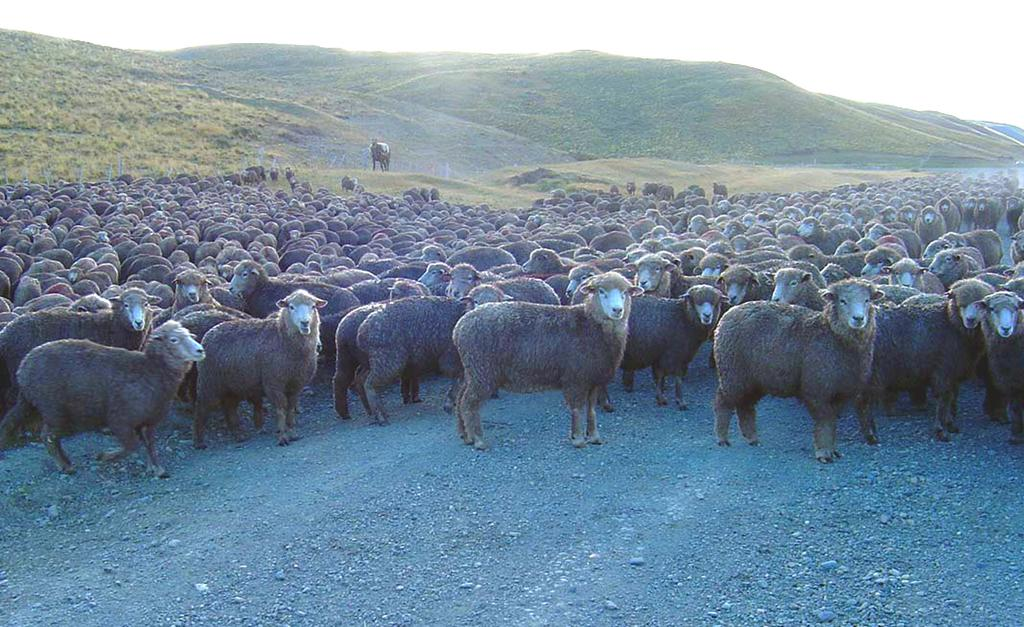What type of animals are in the image? There is a cattle of sheep in the image. What is located at the bottom of the image? There is a road at the bottom of the image. What can be seen in the background of the image? The background of the image includes mountains covered with green grass. What is visible at the top of the image? The sky is visible at the top of the image. How many goats are present in the image? There are no goats present in the image; it features a cattle of sheep. What type of plantation can be seen in the image? There is no plantation present in the image; it features a cattle of sheep, mountains, and a road. 